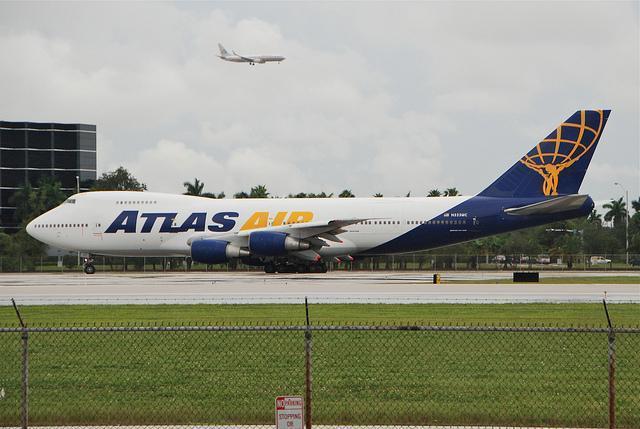How many planes are there?
Give a very brief answer. 2. 